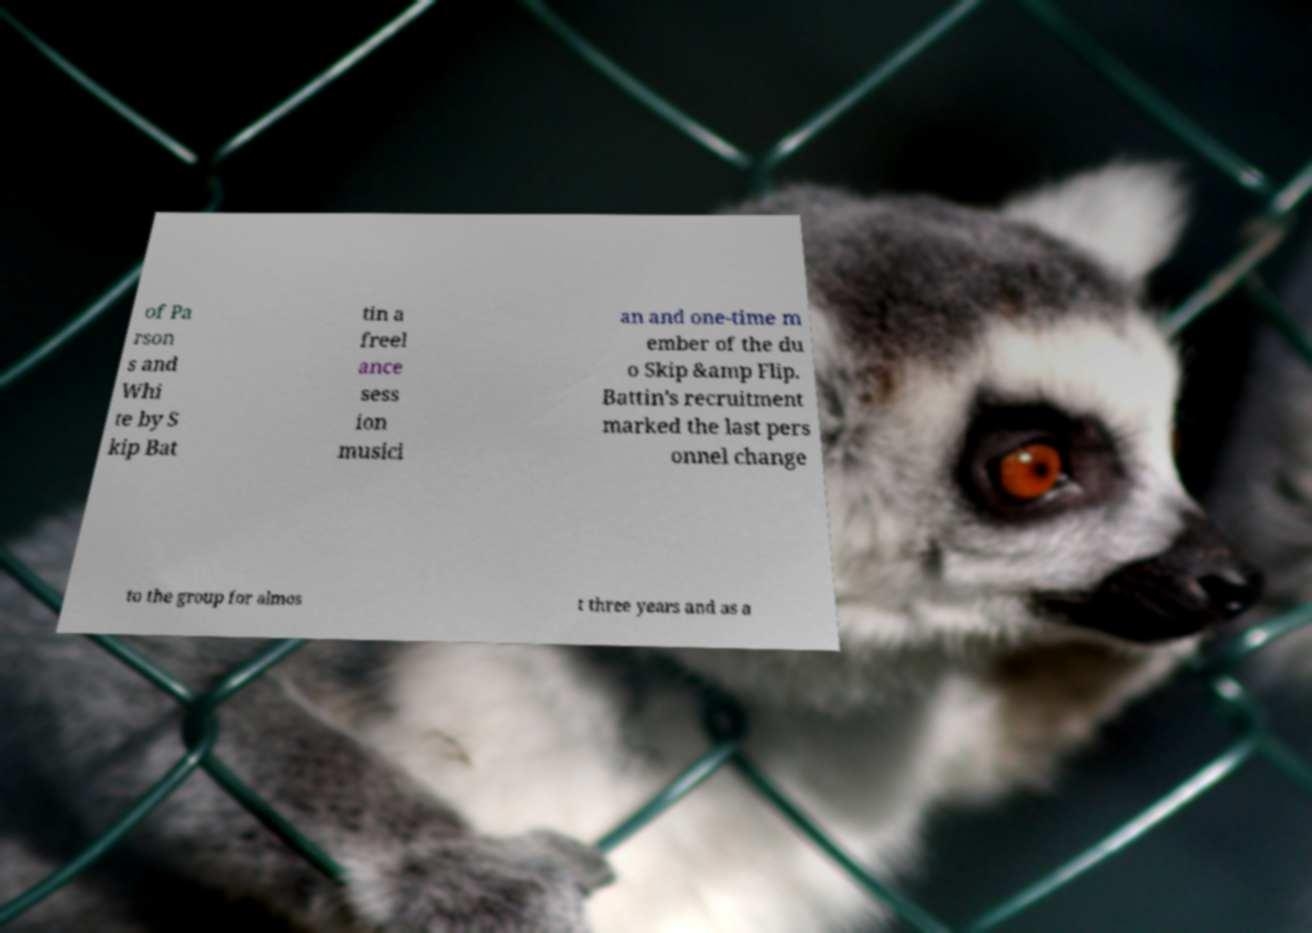What messages or text are displayed in this image? I need them in a readable, typed format. of Pa rson s and Whi te by S kip Bat tin a freel ance sess ion musici an and one-time m ember of the du o Skip &amp Flip. Battin's recruitment marked the last pers onnel change to the group for almos t three years and as a 